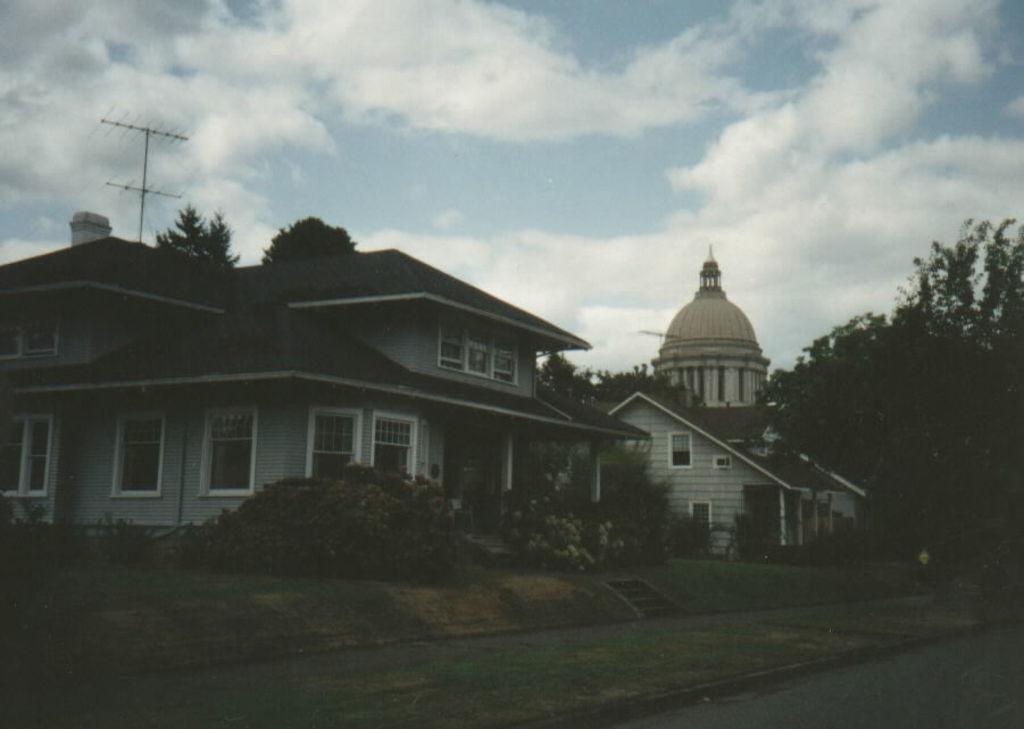Could you give a brief overview of what you see in this image? In this picture we can see few buildings and trees, in the background we can see clouds. 